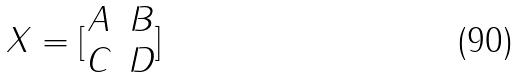<formula> <loc_0><loc_0><loc_500><loc_500>X = [ \begin{matrix} A & B \\ C & D \end{matrix} ]</formula> 